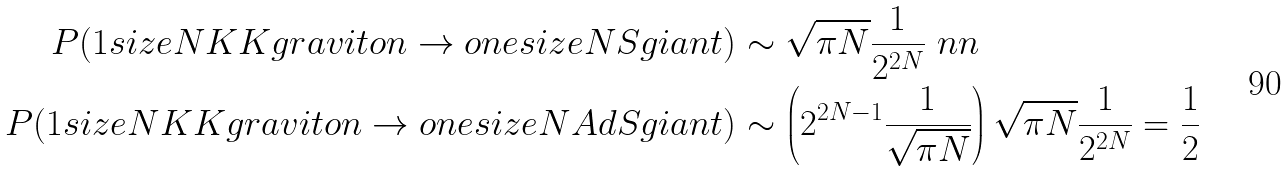<formula> <loc_0><loc_0><loc_500><loc_500>P ( 1 s i z e N K K g r a v i t o n \to o n e s i z e N S g i a n t ) & \sim \sqrt { \pi N } \frac { 1 } { 2 ^ { 2 N } } \ n n \\ P ( 1 s i z e N K K g r a v i t o n \to o n e s i z e N A d S g i a n t ) & \sim \left ( 2 ^ { 2 N - 1 } \frac { 1 } { \sqrt { \pi N } } \right ) \sqrt { \pi N } \frac { 1 } { 2 ^ { 2 N } } = \frac { 1 } { 2 }</formula> 